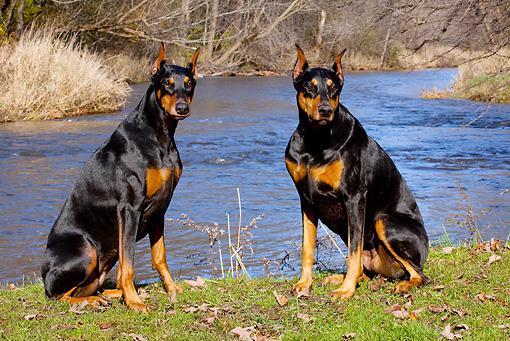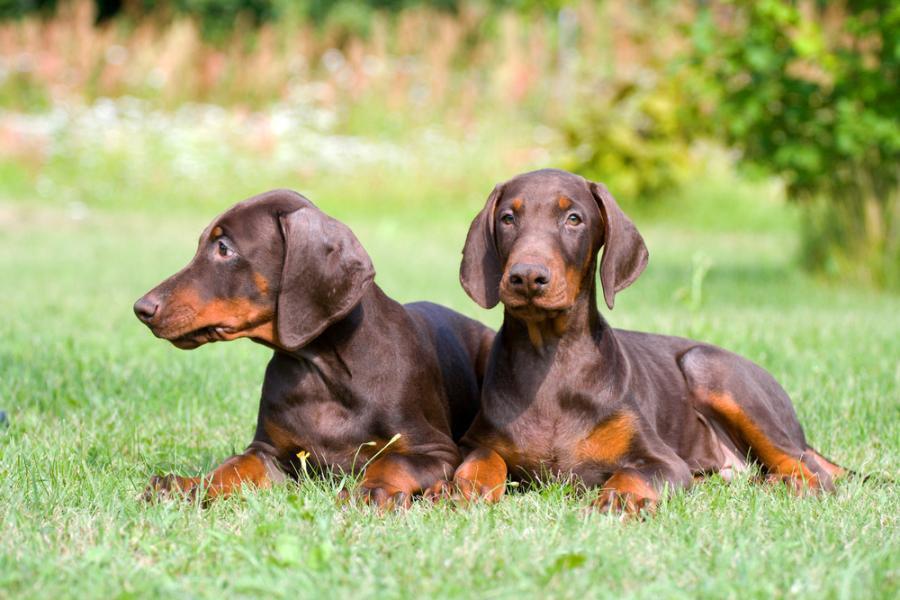The first image is the image on the left, the second image is the image on the right. Given the left and right images, does the statement "The right image contains exactly two dogs." hold true? Answer yes or no. Yes. The first image is the image on the left, the second image is the image on the right. Analyze the images presented: Is the assertion "A total of three pointy-eared black-and-tan dobermans are shown, with at least one staring directly at the camera, and at least one gazing rightward." valid? Answer yes or no. No. 